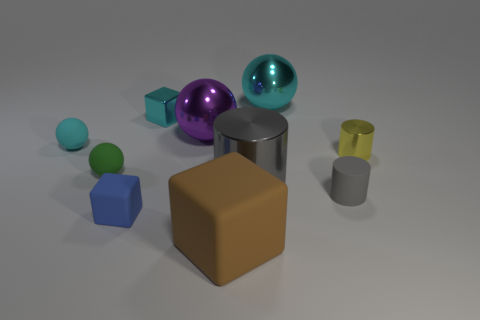Is the matte cylinder the same color as the large cylinder?
Keep it short and to the point. Yes. Do the big sphere on the right side of the large purple metallic ball and the metallic cube have the same color?
Your answer should be very brief. Yes. What is the shape of the tiny cyan object that is the same material as the big purple sphere?
Offer a terse response. Cube. What color is the tiny thing that is both in front of the big cylinder and to the left of the small matte cylinder?
Make the answer very short. Blue. There is a cyan ball that is behind the tiny cyan object to the left of the tiny blue matte cube; what size is it?
Your answer should be compact. Large. Are there any tiny spheres that have the same color as the metal cube?
Give a very brief answer. Yes. Are there an equal number of brown rubber things on the left side of the small matte cube and cyan metal things?
Ensure brevity in your answer.  No. How many cyan objects are there?
Provide a succinct answer. 3. There is a small thing that is both behind the small gray matte cylinder and to the right of the brown object; what shape is it?
Your answer should be compact. Cylinder. Is the color of the big object that is behind the big purple ball the same as the cube that is behind the gray matte cylinder?
Your answer should be very brief. Yes. 